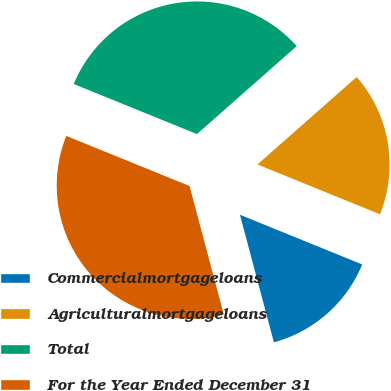Convert chart to OTSL. <chart><loc_0><loc_0><loc_500><loc_500><pie_chart><fcel>Commercialmortgageloans<fcel>Agriculturalmortgageloans<fcel>Total<fcel>For the Year Ended December 31<nl><fcel>14.71%<fcel>17.65%<fcel>32.35%<fcel>35.29%<nl></chart> 